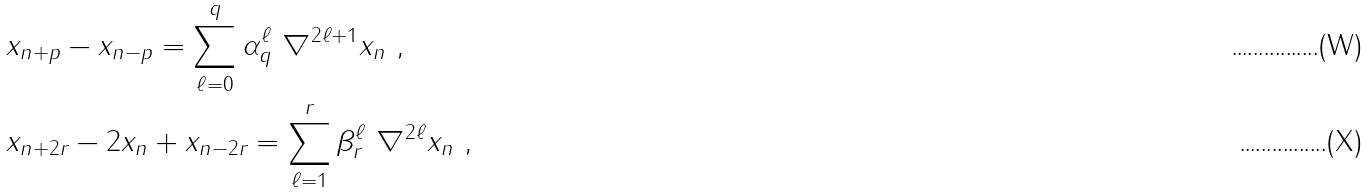Convert formula to latex. <formula><loc_0><loc_0><loc_500><loc_500>& x _ { n + p } - x _ { n - p } = \sum _ { \ell = 0 } ^ { q } \alpha _ { q } ^ { \ell } \ \nabla ^ { 2 \ell + 1 } x _ { n } \ , \\ & x _ { n + 2 r } - 2 x _ { n } + x _ { n - 2 r } = \sum _ { \ell = 1 } ^ { r } \beta _ { r } ^ { \ell } \ \nabla ^ { 2 \ell } x _ { n } \ ,</formula> 